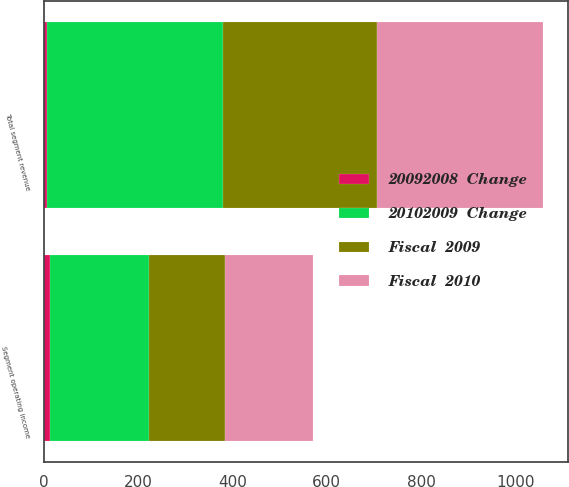Convert chart. <chart><loc_0><loc_0><loc_500><loc_500><stacked_bar_chart><ecel><fcel>Total segment revenue<fcel>Segment operating income<nl><fcel>20102009  Change<fcel>373<fcel>210<nl><fcel>Fiscal  2010<fcel>352<fcel>186<nl><fcel>Fiscal  2009<fcel>327<fcel>162<nl><fcel>20092008  Change<fcel>6<fcel>13<nl></chart> 